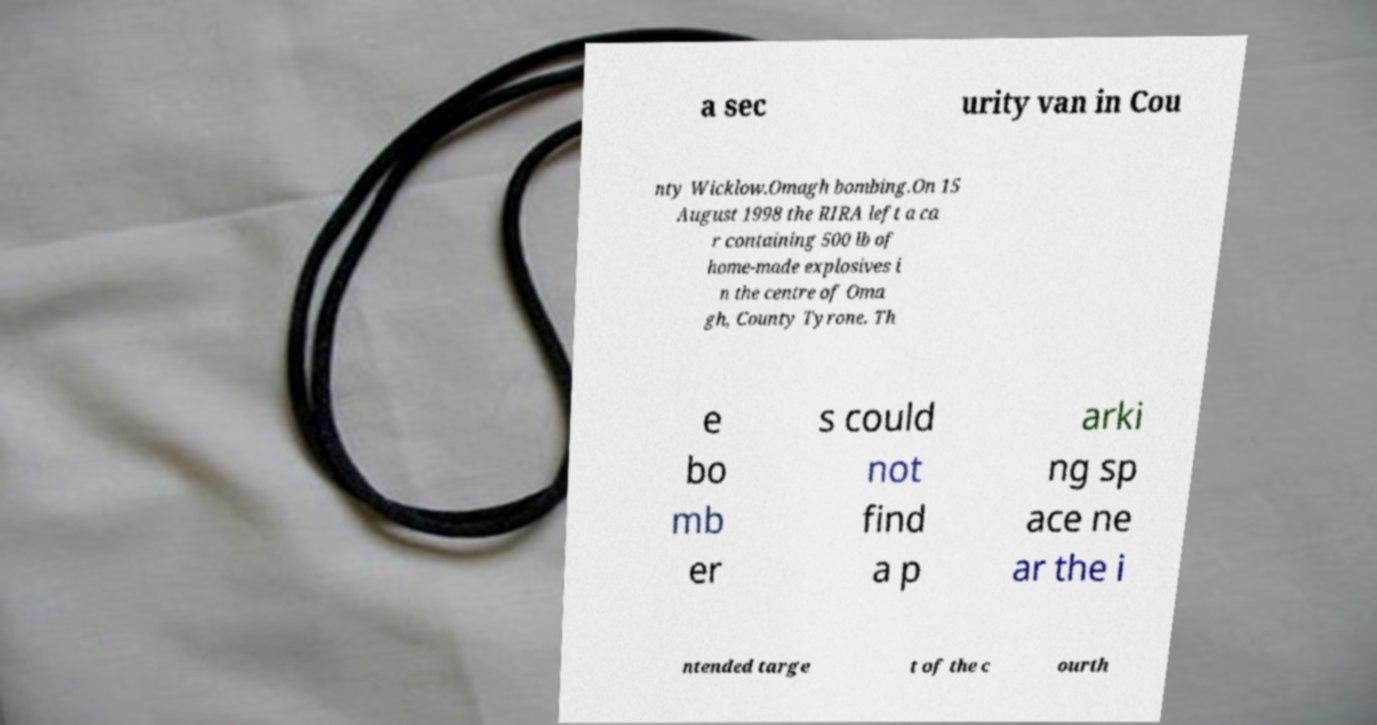Can you read and provide the text displayed in the image?This photo seems to have some interesting text. Can you extract and type it out for me? a sec urity van in Cou nty Wicklow.Omagh bombing.On 15 August 1998 the RIRA left a ca r containing 500 lb of home-made explosives i n the centre of Oma gh, County Tyrone. Th e bo mb er s could not find a p arki ng sp ace ne ar the i ntended targe t of the c ourth 